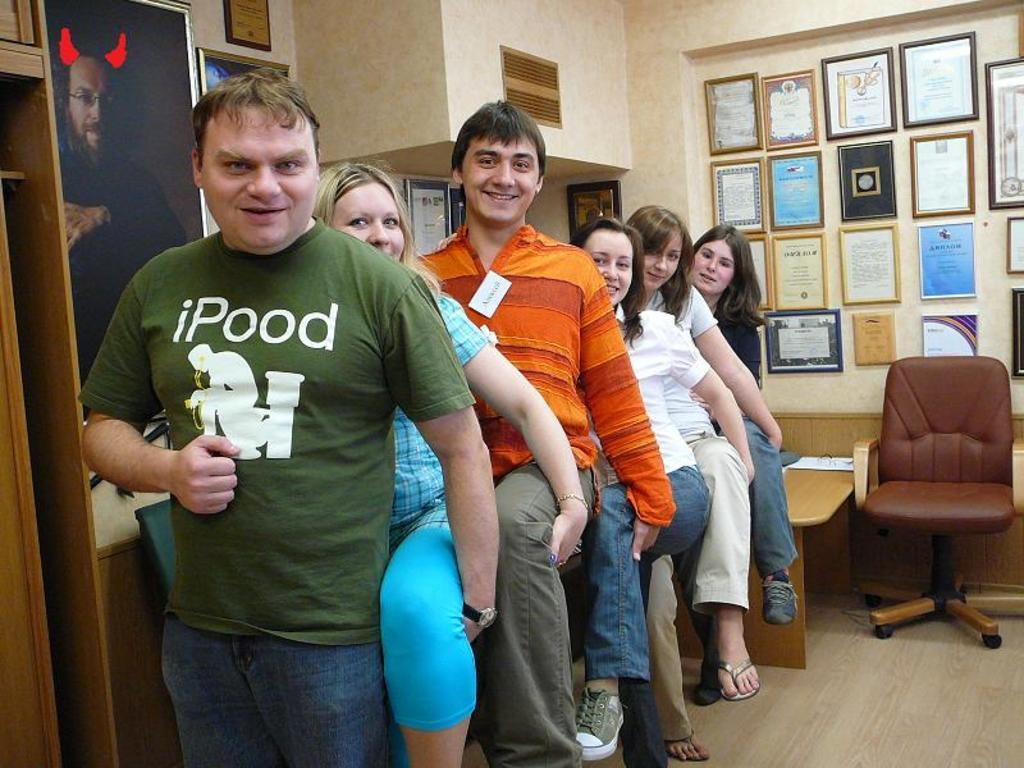What is happening in the image? There is a group of people standing in the image. Can you describe the position of the chair in the image? There is a chair at the back of the group. What can be seen attached to the wall in the image? There are boards attached to the wall in the image. What type of spark can be seen coming from the chair in the image? There is no spark present in the image; the chair is simply positioned at the back of the group. 